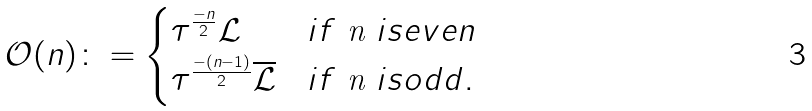Convert formula to latex. <formula><loc_0><loc_0><loc_500><loc_500>\mathcal { O } ( n ) \colon = \begin{cases} \tau ^ { \frac { - n } { 2 } } \mathcal { L } & i f $ n $ i s e v e n \\ \tau ^ { \frac { - ( n - 1 ) } { 2 } } \overline { \mathcal { L } } & i f $ n $ i s o d d . \end{cases}</formula> 